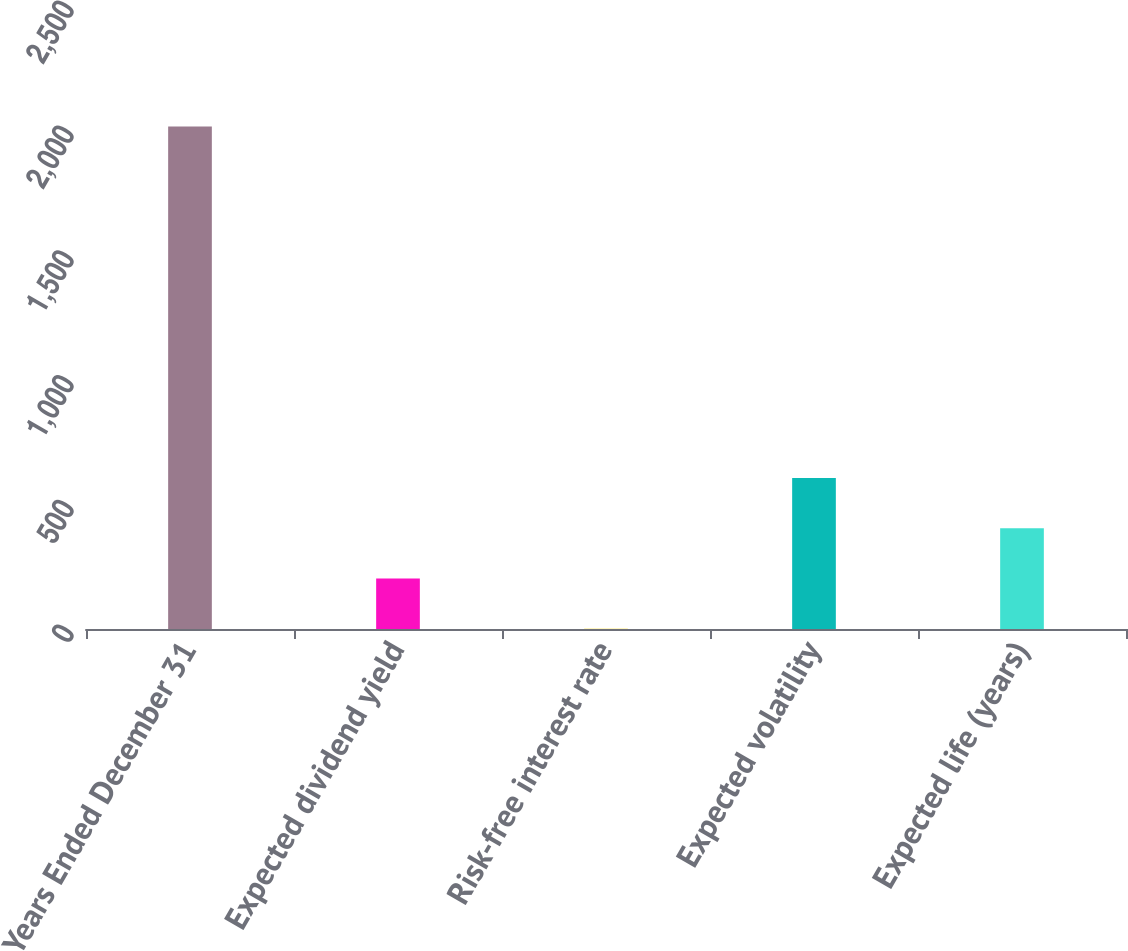Convert chart to OTSL. <chart><loc_0><loc_0><loc_500><loc_500><bar_chart><fcel>Years Ended December 31<fcel>Expected dividend yield<fcel>Risk-free interest rate<fcel>Expected volatility<fcel>Expected life (years)<nl><fcel>2013<fcel>202.38<fcel>1.2<fcel>604.74<fcel>403.56<nl></chart> 